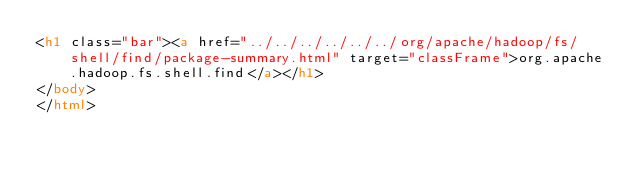Convert code to text. <code><loc_0><loc_0><loc_500><loc_500><_HTML_><h1 class="bar"><a href="../../../../../../org/apache/hadoop/fs/shell/find/package-summary.html" target="classFrame">org.apache.hadoop.fs.shell.find</a></h1>
</body>
</html>
</code> 